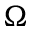<formula> <loc_0><loc_0><loc_500><loc_500>\Omega</formula> 